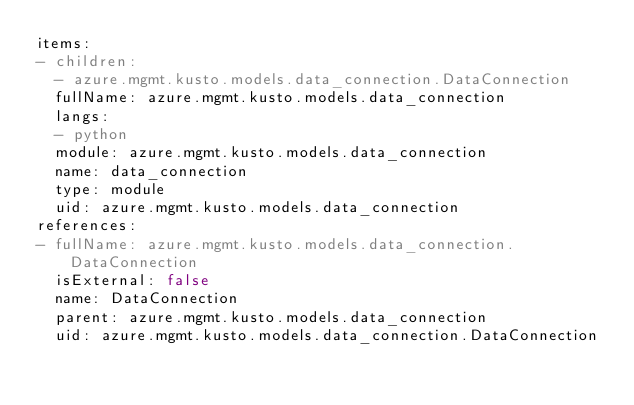<code> <loc_0><loc_0><loc_500><loc_500><_YAML_>items:
- children:
  - azure.mgmt.kusto.models.data_connection.DataConnection
  fullName: azure.mgmt.kusto.models.data_connection
  langs:
  - python
  module: azure.mgmt.kusto.models.data_connection
  name: data_connection
  type: module
  uid: azure.mgmt.kusto.models.data_connection
references:
- fullName: azure.mgmt.kusto.models.data_connection.DataConnection
  isExternal: false
  name: DataConnection
  parent: azure.mgmt.kusto.models.data_connection
  uid: azure.mgmt.kusto.models.data_connection.DataConnection
</code> 